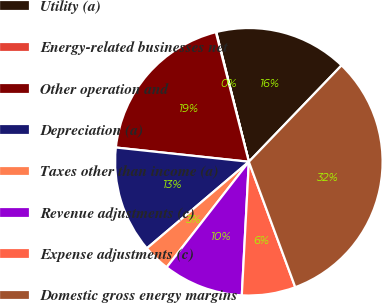Convert chart to OTSL. <chart><loc_0><loc_0><loc_500><loc_500><pie_chart><fcel>Utility (a)<fcel>Energy-related businesses net<fcel>Other operation and<fcel>Depreciation (a)<fcel>Taxes other than income (a)<fcel>Revenue adjustments (c)<fcel>Expense adjustments (c)<fcel>Domestic gross energy margins<nl><fcel>16.11%<fcel>0.05%<fcel>19.33%<fcel>12.9%<fcel>3.27%<fcel>9.69%<fcel>6.48%<fcel>32.17%<nl></chart> 